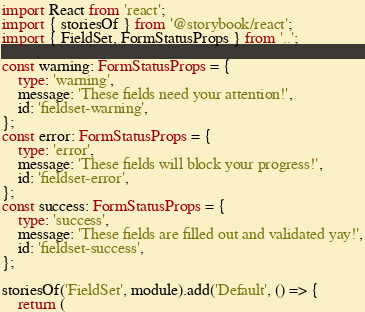<code> <loc_0><loc_0><loc_500><loc_500><_TypeScript_>import React from 'react';
import { storiesOf } from '@storybook/react';
import { FieldSet, FormStatusProps } from '..';

const warning: FormStatusProps = {
	type: 'warning',
	message: 'These fields need your attention!',
	id: 'fieldset-warning',
};
const error: FormStatusProps = {
	type: 'error',
	message: 'These fields will block your progress!',
	id: 'fieldset-error',
};
const success: FormStatusProps = {
	type: 'success',
	message: 'These fields are filled out and validated yay!',
	id: 'fieldset-success',
};

storiesOf('FieldSet', module).add('Default', () => {
	return (</code> 